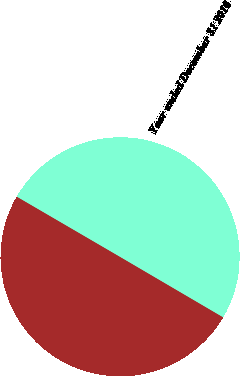<chart> <loc_0><loc_0><loc_500><loc_500><pie_chart><fcel>Year ended December 31 2017<fcel>Year ended December 31 2016<nl><fcel>49.96%<fcel>50.04%<nl></chart> 